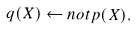Convert formula to latex. <formula><loc_0><loc_0><loc_500><loc_500>q ( X ) \leftarrow n o t p ( X ) .</formula> 